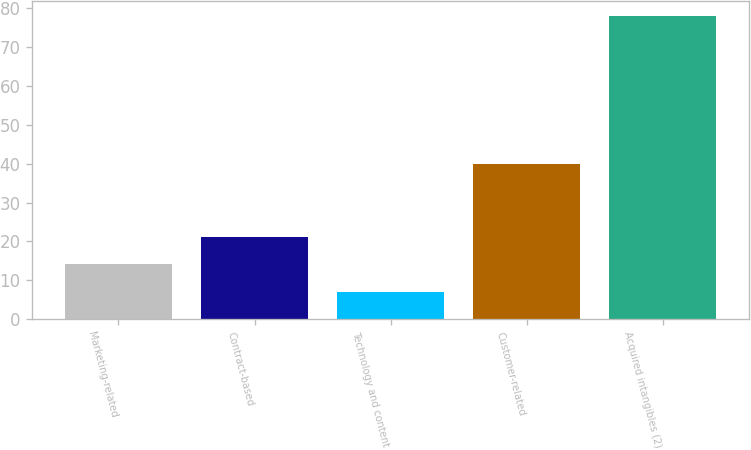Convert chart. <chart><loc_0><loc_0><loc_500><loc_500><bar_chart><fcel>Marketing-related<fcel>Contract-based<fcel>Technology and content<fcel>Customer-related<fcel>Acquired intangibles (2)<nl><fcel>14.1<fcel>21.2<fcel>7<fcel>40<fcel>78<nl></chart> 